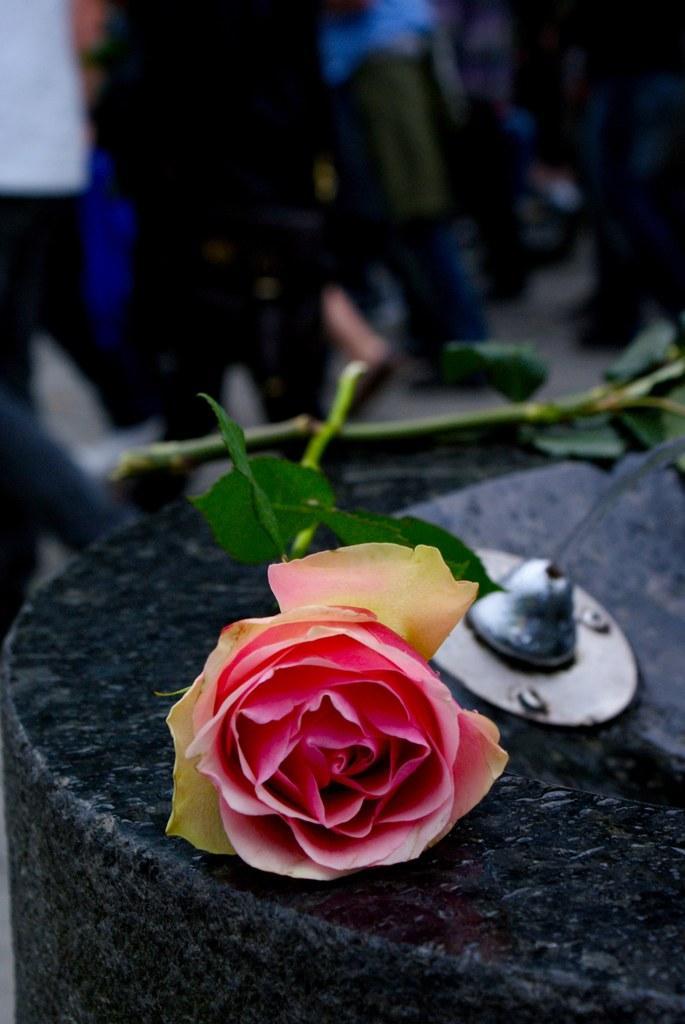In one or two sentences, can you explain what this image depicts? In this image we can see two roses on the stone wall, there we can see a metal object and few people. 